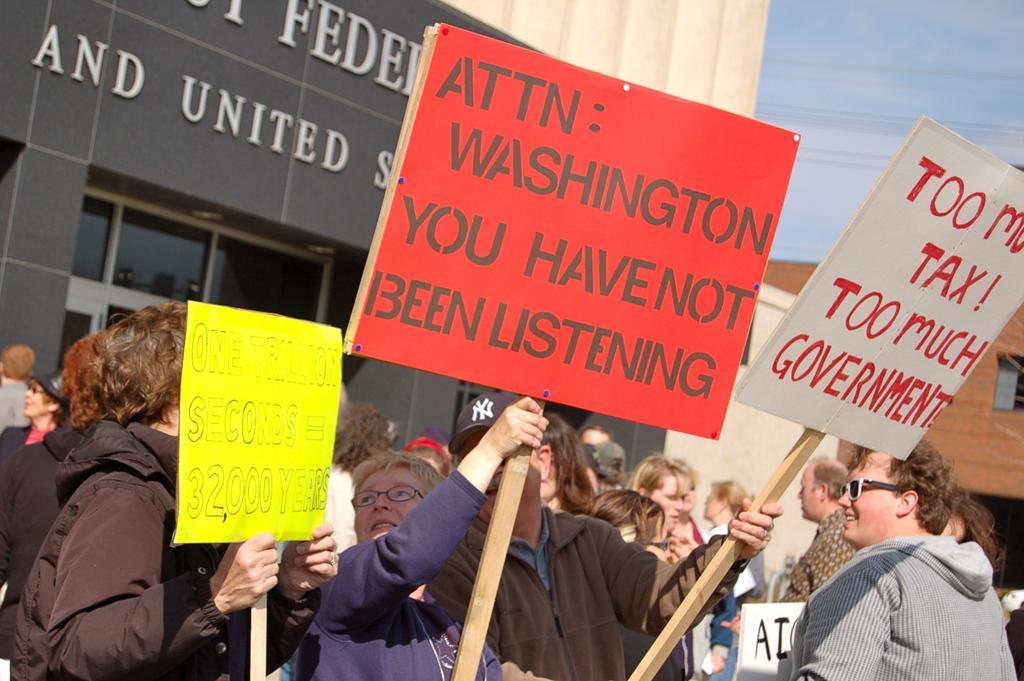Can you describe this image briefly? In the background we can see the sky, transmission wires, window, boards and walls. In this picture we can see the people holding boards and looks like they are protesting. On the right side of the picture we can see a person wearing goggles, jacket and smiling. 